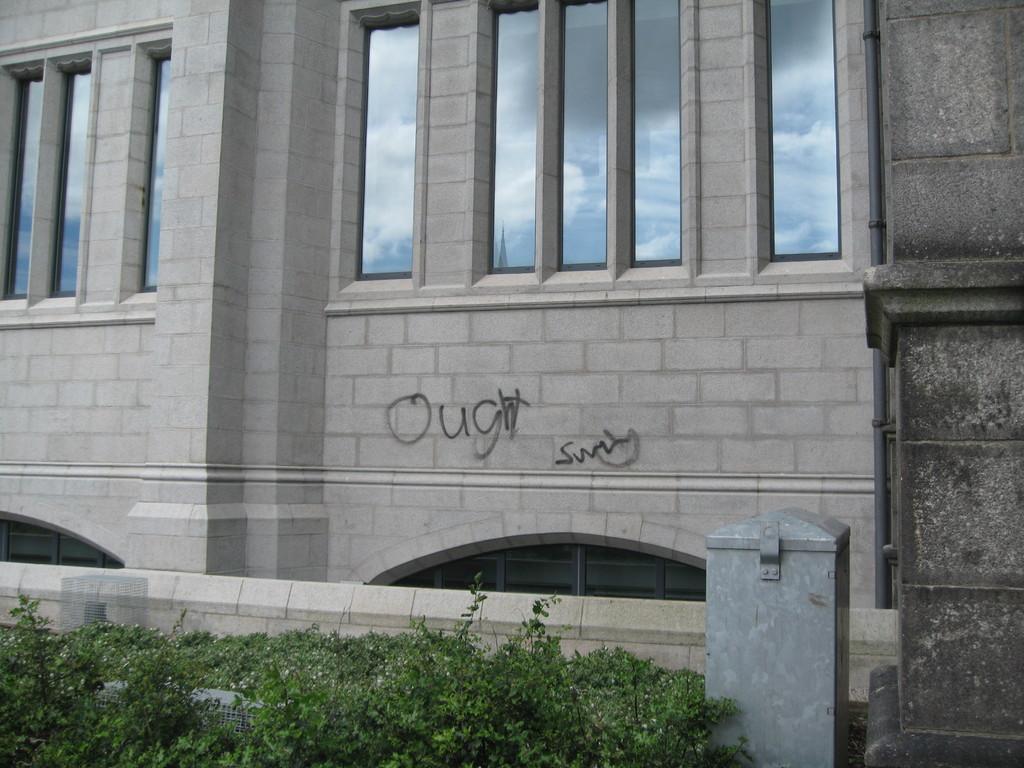Describe this image in one or two sentences. In the center of the image there is a building. There are windows. At the bottom of the image there are plants. There is a wall to the right side of the image. 